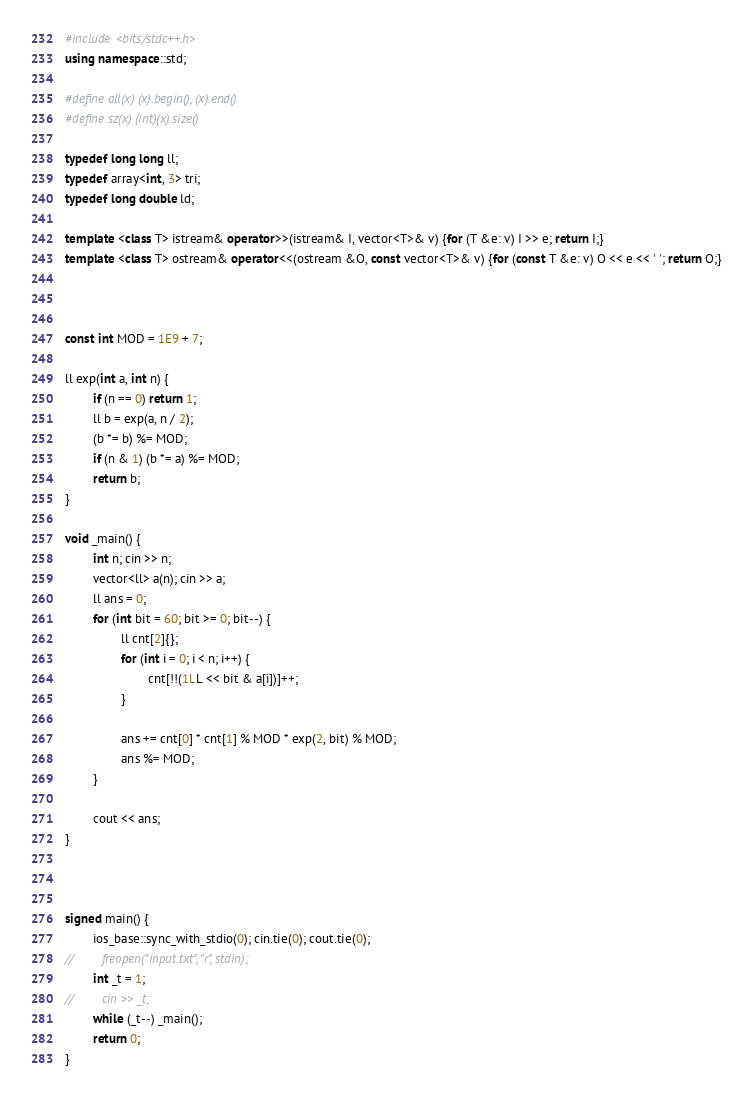<code> <loc_0><loc_0><loc_500><loc_500><_C++_>#include <bits/stdc++.h>
using namespace::std;

#define all(x) (x).begin(), (x).end()
#define sz(x) (int)(x).size()

typedef long long ll;
typedef array<int, 3> tri;
typedef long double ld;

template <class T> istream& operator>>(istream& I, vector<T>& v) {for (T &e: v) I >> e; return I;}
template <class T> ostream& operator<<(ostream &O, const vector<T>& v) {for (const T &e: v) O << e << ' '; return O;}



const int MOD = 1E9 + 7;

ll exp(int a, int n) {
        if (n == 0) return 1;
        ll b = exp(a, n / 2);
        (b *= b) %= MOD;
        if (n & 1) (b *= a) %= MOD;
        return b;
}

void _main() {
        int n; cin >> n;
        vector<ll> a(n); cin >> a;
        ll ans = 0;
        for (int bit = 60; bit >= 0; bit--) {
                ll cnt[2]{};
                for (int i = 0; i < n; i++) {
                        cnt[!!(1LL << bit & a[i])]++;
                }

                ans += cnt[0] * cnt[1] % MOD * exp(2, bit) % MOD;
                ans %= MOD;
        }

        cout << ans;
}



signed main() {
        ios_base::sync_with_stdio(0); cin.tie(0); cout.tie(0);
//        freopen("input.txt", "r", stdin);
        int _t = 1;
//        cin >> _t;
        while (_t--) _main();
        return 0;
}
</code> 